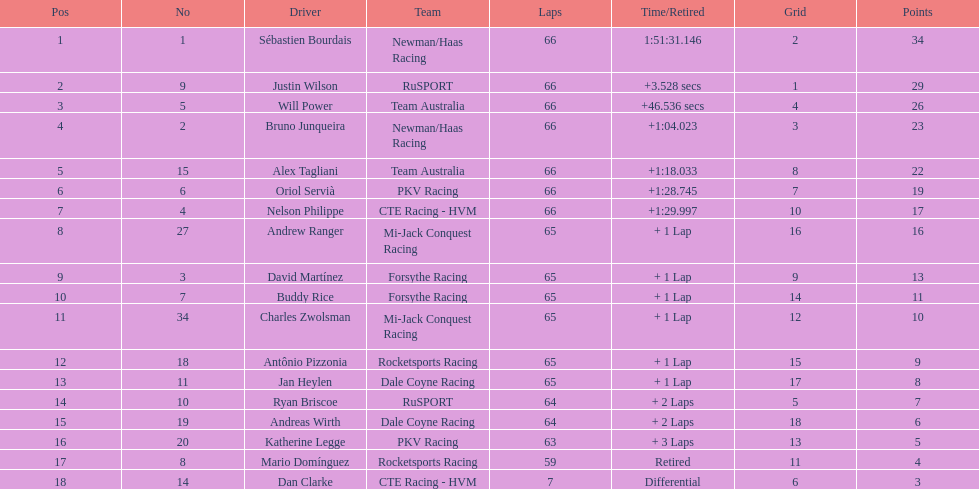Who earned the most points at the 2006 gran premio telmex? Sébastien Bourdais. 